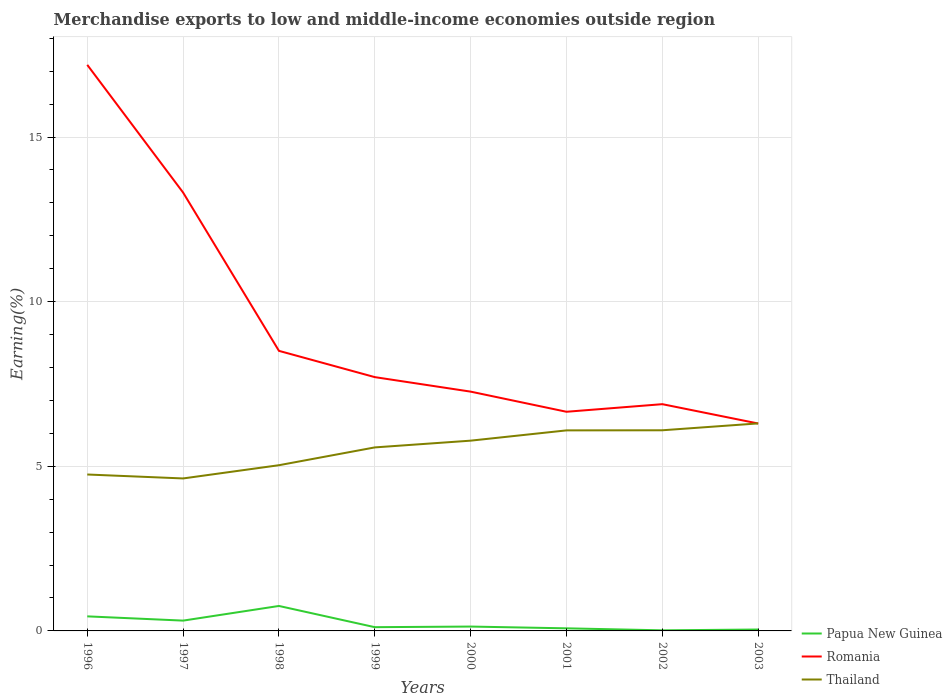How many different coloured lines are there?
Provide a succinct answer. 3. Does the line corresponding to Papua New Guinea intersect with the line corresponding to Thailand?
Your answer should be very brief. No. Is the number of lines equal to the number of legend labels?
Make the answer very short. Yes. Across all years, what is the maximum percentage of amount earned from merchandise exports in Thailand?
Keep it short and to the point. 4.63. In which year was the percentage of amount earned from merchandise exports in Romania maximum?
Give a very brief answer. 2003. What is the total percentage of amount earned from merchandise exports in Papua New Guinea in the graph?
Offer a very short reply. 0.27. What is the difference between the highest and the second highest percentage of amount earned from merchandise exports in Papua New Guinea?
Your response must be concise. 0.74. Is the percentage of amount earned from merchandise exports in Papua New Guinea strictly greater than the percentage of amount earned from merchandise exports in Romania over the years?
Keep it short and to the point. Yes. How many lines are there?
Give a very brief answer. 3. What is the difference between two consecutive major ticks on the Y-axis?
Offer a very short reply. 5. Are the values on the major ticks of Y-axis written in scientific E-notation?
Offer a very short reply. No. Does the graph contain grids?
Your response must be concise. Yes. How many legend labels are there?
Keep it short and to the point. 3. What is the title of the graph?
Ensure brevity in your answer.  Merchandise exports to low and middle-income economies outside region. Does "Azerbaijan" appear as one of the legend labels in the graph?
Your answer should be compact. No. What is the label or title of the X-axis?
Keep it short and to the point. Years. What is the label or title of the Y-axis?
Your answer should be very brief. Earning(%). What is the Earning(%) of Papua New Guinea in 1996?
Ensure brevity in your answer.  0.44. What is the Earning(%) in Romania in 1996?
Offer a terse response. 17.19. What is the Earning(%) in Thailand in 1996?
Provide a succinct answer. 4.75. What is the Earning(%) of Papua New Guinea in 1997?
Your answer should be compact. 0.31. What is the Earning(%) of Romania in 1997?
Your answer should be compact. 13.31. What is the Earning(%) of Thailand in 1997?
Offer a very short reply. 4.63. What is the Earning(%) in Papua New Guinea in 1998?
Ensure brevity in your answer.  0.76. What is the Earning(%) in Romania in 1998?
Make the answer very short. 8.51. What is the Earning(%) in Thailand in 1998?
Make the answer very short. 5.03. What is the Earning(%) in Papua New Guinea in 1999?
Keep it short and to the point. 0.11. What is the Earning(%) in Romania in 1999?
Ensure brevity in your answer.  7.71. What is the Earning(%) in Thailand in 1999?
Ensure brevity in your answer.  5.57. What is the Earning(%) in Papua New Guinea in 2000?
Provide a short and direct response. 0.13. What is the Earning(%) in Romania in 2000?
Your answer should be very brief. 7.27. What is the Earning(%) in Thailand in 2000?
Give a very brief answer. 5.78. What is the Earning(%) of Papua New Guinea in 2001?
Your response must be concise. 0.08. What is the Earning(%) in Romania in 2001?
Provide a succinct answer. 6.66. What is the Earning(%) of Thailand in 2001?
Keep it short and to the point. 6.09. What is the Earning(%) in Papua New Guinea in 2002?
Offer a terse response. 0.02. What is the Earning(%) of Romania in 2002?
Your response must be concise. 6.89. What is the Earning(%) in Thailand in 2002?
Keep it short and to the point. 6.09. What is the Earning(%) in Papua New Guinea in 2003?
Give a very brief answer. 0.04. What is the Earning(%) of Romania in 2003?
Offer a terse response. 6.3. What is the Earning(%) in Thailand in 2003?
Your answer should be very brief. 6.3. Across all years, what is the maximum Earning(%) in Papua New Guinea?
Your answer should be very brief. 0.76. Across all years, what is the maximum Earning(%) in Romania?
Give a very brief answer. 17.19. Across all years, what is the maximum Earning(%) of Thailand?
Provide a short and direct response. 6.3. Across all years, what is the minimum Earning(%) in Papua New Guinea?
Keep it short and to the point. 0.02. Across all years, what is the minimum Earning(%) of Romania?
Ensure brevity in your answer.  6.3. Across all years, what is the minimum Earning(%) in Thailand?
Give a very brief answer. 4.63. What is the total Earning(%) in Papua New Guinea in the graph?
Your response must be concise. 1.9. What is the total Earning(%) in Romania in the graph?
Give a very brief answer. 73.83. What is the total Earning(%) in Thailand in the graph?
Ensure brevity in your answer.  44.26. What is the difference between the Earning(%) of Papua New Guinea in 1996 and that in 1997?
Provide a short and direct response. 0.13. What is the difference between the Earning(%) of Romania in 1996 and that in 1997?
Your answer should be compact. 3.88. What is the difference between the Earning(%) of Thailand in 1996 and that in 1997?
Your answer should be compact. 0.12. What is the difference between the Earning(%) in Papua New Guinea in 1996 and that in 1998?
Give a very brief answer. -0.32. What is the difference between the Earning(%) in Romania in 1996 and that in 1998?
Offer a very short reply. 8.69. What is the difference between the Earning(%) of Thailand in 1996 and that in 1998?
Your answer should be compact. -0.28. What is the difference between the Earning(%) of Papua New Guinea in 1996 and that in 1999?
Your answer should be very brief. 0.33. What is the difference between the Earning(%) of Romania in 1996 and that in 1999?
Your answer should be compact. 9.48. What is the difference between the Earning(%) in Thailand in 1996 and that in 1999?
Provide a short and direct response. -0.82. What is the difference between the Earning(%) in Papua New Guinea in 1996 and that in 2000?
Ensure brevity in your answer.  0.31. What is the difference between the Earning(%) in Romania in 1996 and that in 2000?
Ensure brevity in your answer.  9.93. What is the difference between the Earning(%) in Thailand in 1996 and that in 2000?
Offer a terse response. -1.03. What is the difference between the Earning(%) in Papua New Guinea in 1996 and that in 2001?
Offer a very short reply. 0.36. What is the difference between the Earning(%) of Romania in 1996 and that in 2001?
Your answer should be very brief. 10.54. What is the difference between the Earning(%) in Thailand in 1996 and that in 2001?
Your answer should be compact. -1.34. What is the difference between the Earning(%) in Papua New Guinea in 1996 and that in 2002?
Offer a very short reply. 0.42. What is the difference between the Earning(%) of Romania in 1996 and that in 2002?
Your response must be concise. 10.31. What is the difference between the Earning(%) of Thailand in 1996 and that in 2002?
Your answer should be compact. -1.34. What is the difference between the Earning(%) of Papua New Guinea in 1996 and that in 2003?
Offer a terse response. 0.4. What is the difference between the Earning(%) in Romania in 1996 and that in 2003?
Provide a succinct answer. 10.89. What is the difference between the Earning(%) in Thailand in 1996 and that in 2003?
Your response must be concise. -1.55. What is the difference between the Earning(%) of Papua New Guinea in 1997 and that in 1998?
Make the answer very short. -0.45. What is the difference between the Earning(%) of Romania in 1997 and that in 1998?
Your response must be concise. 4.81. What is the difference between the Earning(%) in Thailand in 1997 and that in 1998?
Provide a succinct answer. -0.4. What is the difference between the Earning(%) in Papua New Guinea in 1997 and that in 1999?
Keep it short and to the point. 0.2. What is the difference between the Earning(%) in Romania in 1997 and that in 1999?
Your answer should be compact. 5.61. What is the difference between the Earning(%) in Thailand in 1997 and that in 1999?
Provide a succinct answer. -0.94. What is the difference between the Earning(%) in Papua New Guinea in 1997 and that in 2000?
Give a very brief answer. 0.18. What is the difference between the Earning(%) of Romania in 1997 and that in 2000?
Your answer should be compact. 6.05. What is the difference between the Earning(%) in Thailand in 1997 and that in 2000?
Ensure brevity in your answer.  -1.15. What is the difference between the Earning(%) of Papua New Guinea in 1997 and that in 2001?
Your response must be concise. 0.23. What is the difference between the Earning(%) in Romania in 1997 and that in 2001?
Offer a very short reply. 6.66. What is the difference between the Earning(%) in Thailand in 1997 and that in 2001?
Offer a terse response. -1.46. What is the difference between the Earning(%) of Papua New Guinea in 1997 and that in 2002?
Keep it short and to the point. 0.29. What is the difference between the Earning(%) in Romania in 1997 and that in 2002?
Offer a terse response. 6.43. What is the difference between the Earning(%) in Thailand in 1997 and that in 2002?
Give a very brief answer. -1.46. What is the difference between the Earning(%) of Papua New Guinea in 1997 and that in 2003?
Your answer should be compact. 0.27. What is the difference between the Earning(%) of Romania in 1997 and that in 2003?
Keep it short and to the point. 7.01. What is the difference between the Earning(%) of Thailand in 1997 and that in 2003?
Make the answer very short. -1.67. What is the difference between the Earning(%) in Papua New Guinea in 1998 and that in 1999?
Provide a succinct answer. 0.64. What is the difference between the Earning(%) of Romania in 1998 and that in 1999?
Make the answer very short. 0.8. What is the difference between the Earning(%) of Thailand in 1998 and that in 1999?
Your answer should be compact. -0.54. What is the difference between the Earning(%) of Papua New Guinea in 1998 and that in 2000?
Keep it short and to the point. 0.63. What is the difference between the Earning(%) of Romania in 1998 and that in 2000?
Your answer should be very brief. 1.24. What is the difference between the Earning(%) of Thailand in 1998 and that in 2000?
Your answer should be compact. -0.75. What is the difference between the Earning(%) of Papua New Guinea in 1998 and that in 2001?
Give a very brief answer. 0.68. What is the difference between the Earning(%) of Romania in 1998 and that in 2001?
Make the answer very short. 1.85. What is the difference between the Earning(%) in Thailand in 1998 and that in 2001?
Offer a very short reply. -1.06. What is the difference between the Earning(%) in Papua New Guinea in 1998 and that in 2002?
Make the answer very short. 0.74. What is the difference between the Earning(%) in Romania in 1998 and that in 2002?
Your answer should be very brief. 1.62. What is the difference between the Earning(%) of Thailand in 1998 and that in 2002?
Your answer should be compact. -1.06. What is the difference between the Earning(%) in Papua New Guinea in 1998 and that in 2003?
Give a very brief answer. 0.72. What is the difference between the Earning(%) in Romania in 1998 and that in 2003?
Your answer should be very brief. 2.21. What is the difference between the Earning(%) in Thailand in 1998 and that in 2003?
Your response must be concise. -1.27. What is the difference between the Earning(%) of Papua New Guinea in 1999 and that in 2000?
Provide a succinct answer. -0.02. What is the difference between the Earning(%) in Romania in 1999 and that in 2000?
Make the answer very short. 0.44. What is the difference between the Earning(%) of Thailand in 1999 and that in 2000?
Give a very brief answer. -0.21. What is the difference between the Earning(%) in Papua New Guinea in 1999 and that in 2001?
Provide a succinct answer. 0.03. What is the difference between the Earning(%) of Romania in 1999 and that in 2001?
Provide a short and direct response. 1.05. What is the difference between the Earning(%) of Thailand in 1999 and that in 2001?
Provide a succinct answer. -0.52. What is the difference between the Earning(%) in Papua New Guinea in 1999 and that in 2002?
Give a very brief answer. 0.1. What is the difference between the Earning(%) in Romania in 1999 and that in 2002?
Your response must be concise. 0.82. What is the difference between the Earning(%) of Thailand in 1999 and that in 2002?
Your response must be concise. -0.52. What is the difference between the Earning(%) in Papua New Guinea in 1999 and that in 2003?
Offer a terse response. 0.07. What is the difference between the Earning(%) in Romania in 1999 and that in 2003?
Ensure brevity in your answer.  1.41. What is the difference between the Earning(%) in Thailand in 1999 and that in 2003?
Offer a terse response. -0.73. What is the difference between the Earning(%) in Papua New Guinea in 2000 and that in 2001?
Ensure brevity in your answer.  0.05. What is the difference between the Earning(%) in Romania in 2000 and that in 2001?
Provide a short and direct response. 0.61. What is the difference between the Earning(%) in Thailand in 2000 and that in 2001?
Ensure brevity in your answer.  -0.31. What is the difference between the Earning(%) in Papua New Guinea in 2000 and that in 2002?
Make the answer very short. 0.11. What is the difference between the Earning(%) in Romania in 2000 and that in 2002?
Your answer should be very brief. 0.38. What is the difference between the Earning(%) of Thailand in 2000 and that in 2002?
Offer a terse response. -0.32. What is the difference between the Earning(%) in Papua New Guinea in 2000 and that in 2003?
Your answer should be compact. 0.09. What is the difference between the Earning(%) of Romania in 2000 and that in 2003?
Make the answer very short. 0.97. What is the difference between the Earning(%) of Thailand in 2000 and that in 2003?
Your answer should be compact. -0.52. What is the difference between the Earning(%) in Papua New Guinea in 2001 and that in 2002?
Your answer should be compact. 0.06. What is the difference between the Earning(%) in Romania in 2001 and that in 2002?
Provide a short and direct response. -0.23. What is the difference between the Earning(%) in Thailand in 2001 and that in 2002?
Offer a very short reply. -0. What is the difference between the Earning(%) of Papua New Guinea in 2001 and that in 2003?
Provide a short and direct response. 0.04. What is the difference between the Earning(%) in Romania in 2001 and that in 2003?
Provide a short and direct response. 0.36. What is the difference between the Earning(%) in Thailand in 2001 and that in 2003?
Offer a terse response. -0.21. What is the difference between the Earning(%) in Papua New Guinea in 2002 and that in 2003?
Provide a succinct answer. -0.02. What is the difference between the Earning(%) of Romania in 2002 and that in 2003?
Your response must be concise. 0.59. What is the difference between the Earning(%) of Thailand in 2002 and that in 2003?
Keep it short and to the point. -0.21. What is the difference between the Earning(%) in Papua New Guinea in 1996 and the Earning(%) in Romania in 1997?
Provide a short and direct response. -12.87. What is the difference between the Earning(%) in Papua New Guinea in 1996 and the Earning(%) in Thailand in 1997?
Make the answer very short. -4.19. What is the difference between the Earning(%) of Romania in 1996 and the Earning(%) of Thailand in 1997?
Provide a short and direct response. 12.56. What is the difference between the Earning(%) of Papua New Guinea in 1996 and the Earning(%) of Romania in 1998?
Your answer should be compact. -8.06. What is the difference between the Earning(%) of Papua New Guinea in 1996 and the Earning(%) of Thailand in 1998?
Provide a succinct answer. -4.59. What is the difference between the Earning(%) in Romania in 1996 and the Earning(%) in Thailand in 1998?
Offer a terse response. 12.16. What is the difference between the Earning(%) of Papua New Guinea in 1996 and the Earning(%) of Romania in 1999?
Your response must be concise. -7.27. What is the difference between the Earning(%) of Papua New Guinea in 1996 and the Earning(%) of Thailand in 1999?
Ensure brevity in your answer.  -5.13. What is the difference between the Earning(%) of Romania in 1996 and the Earning(%) of Thailand in 1999?
Offer a terse response. 11.62. What is the difference between the Earning(%) of Papua New Guinea in 1996 and the Earning(%) of Romania in 2000?
Ensure brevity in your answer.  -6.83. What is the difference between the Earning(%) of Papua New Guinea in 1996 and the Earning(%) of Thailand in 2000?
Provide a succinct answer. -5.34. What is the difference between the Earning(%) of Romania in 1996 and the Earning(%) of Thailand in 2000?
Offer a terse response. 11.41. What is the difference between the Earning(%) of Papua New Guinea in 1996 and the Earning(%) of Romania in 2001?
Offer a terse response. -6.21. What is the difference between the Earning(%) in Papua New Guinea in 1996 and the Earning(%) in Thailand in 2001?
Keep it short and to the point. -5.65. What is the difference between the Earning(%) of Romania in 1996 and the Earning(%) of Thailand in 2001?
Your response must be concise. 11.1. What is the difference between the Earning(%) in Papua New Guinea in 1996 and the Earning(%) in Romania in 2002?
Provide a short and direct response. -6.44. What is the difference between the Earning(%) in Papua New Guinea in 1996 and the Earning(%) in Thailand in 2002?
Offer a terse response. -5.65. What is the difference between the Earning(%) of Romania in 1996 and the Earning(%) of Thailand in 2002?
Your answer should be compact. 11.1. What is the difference between the Earning(%) in Papua New Guinea in 1996 and the Earning(%) in Romania in 2003?
Keep it short and to the point. -5.86. What is the difference between the Earning(%) in Papua New Guinea in 1996 and the Earning(%) in Thailand in 2003?
Your response must be concise. -5.86. What is the difference between the Earning(%) in Romania in 1996 and the Earning(%) in Thailand in 2003?
Your answer should be compact. 10.89. What is the difference between the Earning(%) of Papua New Guinea in 1997 and the Earning(%) of Romania in 1998?
Provide a succinct answer. -8.19. What is the difference between the Earning(%) of Papua New Guinea in 1997 and the Earning(%) of Thailand in 1998?
Offer a very short reply. -4.72. What is the difference between the Earning(%) in Romania in 1997 and the Earning(%) in Thailand in 1998?
Provide a short and direct response. 8.28. What is the difference between the Earning(%) of Papua New Guinea in 1997 and the Earning(%) of Romania in 1999?
Give a very brief answer. -7.4. What is the difference between the Earning(%) in Papua New Guinea in 1997 and the Earning(%) in Thailand in 1999?
Your answer should be very brief. -5.26. What is the difference between the Earning(%) of Romania in 1997 and the Earning(%) of Thailand in 1999?
Keep it short and to the point. 7.74. What is the difference between the Earning(%) in Papua New Guinea in 1997 and the Earning(%) in Romania in 2000?
Your answer should be very brief. -6.95. What is the difference between the Earning(%) in Papua New Guinea in 1997 and the Earning(%) in Thailand in 2000?
Keep it short and to the point. -5.47. What is the difference between the Earning(%) of Romania in 1997 and the Earning(%) of Thailand in 2000?
Keep it short and to the point. 7.54. What is the difference between the Earning(%) in Papua New Guinea in 1997 and the Earning(%) in Romania in 2001?
Your answer should be compact. -6.34. What is the difference between the Earning(%) of Papua New Guinea in 1997 and the Earning(%) of Thailand in 2001?
Ensure brevity in your answer.  -5.78. What is the difference between the Earning(%) in Romania in 1997 and the Earning(%) in Thailand in 2001?
Offer a terse response. 7.22. What is the difference between the Earning(%) of Papua New Guinea in 1997 and the Earning(%) of Romania in 2002?
Your answer should be compact. -6.57. What is the difference between the Earning(%) in Papua New Guinea in 1997 and the Earning(%) in Thailand in 2002?
Provide a succinct answer. -5.78. What is the difference between the Earning(%) in Romania in 1997 and the Earning(%) in Thailand in 2002?
Provide a succinct answer. 7.22. What is the difference between the Earning(%) in Papua New Guinea in 1997 and the Earning(%) in Romania in 2003?
Provide a short and direct response. -5.99. What is the difference between the Earning(%) of Papua New Guinea in 1997 and the Earning(%) of Thailand in 2003?
Provide a succinct answer. -5.99. What is the difference between the Earning(%) in Romania in 1997 and the Earning(%) in Thailand in 2003?
Your answer should be very brief. 7.01. What is the difference between the Earning(%) in Papua New Guinea in 1998 and the Earning(%) in Romania in 1999?
Offer a terse response. -6.95. What is the difference between the Earning(%) in Papua New Guinea in 1998 and the Earning(%) in Thailand in 1999?
Your response must be concise. -4.82. What is the difference between the Earning(%) in Romania in 1998 and the Earning(%) in Thailand in 1999?
Provide a succinct answer. 2.93. What is the difference between the Earning(%) of Papua New Guinea in 1998 and the Earning(%) of Romania in 2000?
Your response must be concise. -6.51. What is the difference between the Earning(%) of Papua New Guinea in 1998 and the Earning(%) of Thailand in 2000?
Keep it short and to the point. -5.02. What is the difference between the Earning(%) in Romania in 1998 and the Earning(%) in Thailand in 2000?
Keep it short and to the point. 2.73. What is the difference between the Earning(%) in Papua New Guinea in 1998 and the Earning(%) in Romania in 2001?
Keep it short and to the point. -5.9. What is the difference between the Earning(%) of Papua New Guinea in 1998 and the Earning(%) of Thailand in 2001?
Your answer should be compact. -5.33. What is the difference between the Earning(%) in Romania in 1998 and the Earning(%) in Thailand in 2001?
Provide a succinct answer. 2.42. What is the difference between the Earning(%) of Papua New Guinea in 1998 and the Earning(%) of Romania in 2002?
Provide a succinct answer. -6.13. What is the difference between the Earning(%) of Papua New Guinea in 1998 and the Earning(%) of Thailand in 2002?
Provide a succinct answer. -5.34. What is the difference between the Earning(%) in Romania in 1998 and the Earning(%) in Thailand in 2002?
Your answer should be compact. 2.41. What is the difference between the Earning(%) of Papua New Guinea in 1998 and the Earning(%) of Romania in 2003?
Your answer should be very brief. -5.54. What is the difference between the Earning(%) in Papua New Guinea in 1998 and the Earning(%) in Thailand in 2003?
Keep it short and to the point. -5.54. What is the difference between the Earning(%) of Romania in 1998 and the Earning(%) of Thailand in 2003?
Make the answer very short. 2.2. What is the difference between the Earning(%) of Papua New Guinea in 1999 and the Earning(%) of Romania in 2000?
Offer a terse response. -7.15. What is the difference between the Earning(%) of Papua New Guinea in 1999 and the Earning(%) of Thailand in 2000?
Your answer should be compact. -5.67. What is the difference between the Earning(%) in Romania in 1999 and the Earning(%) in Thailand in 2000?
Your answer should be very brief. 1.93. What is the difference between the Earning(%) of Papua New Guinea in 1999 and the Earning(%) of Romania in 2001?
Provide a succinct answer. -6.54. What is the difference between the Earning(%) of Papua New Guinea in 1999 and the Earning(%) of Thailand in 2001?
Your answer should be compact. -5.98. What is the difference between the Earning(%) of Romania in 1999 and the Earning(%) of Thailand in 2001?
Ensure brevity in your answer.  1.62. What is the difference between the Earning(%) in Papua New Guinea in 1999 and the Earning(%) in Romania in 2002?
Make the answer very short. -6.77. What is the difference between the Earning(%) in Papua New Guinea in 1999 and the Earning(%) in Thailand in 2002?
Ensure brevity in your answer.  -5.98. What is the difference between the Earning(%) in Romania in 1999 and the Earning(%) in Thailand in 2002?
Provide a succinct answer. 1.61. What is the difference between the Earning(%) in Papua New Guinea in 1999 and the Earning(%) in Romania in 2003?
Provide a succinct answer. -6.19. What is the difference between the Earning(%) of Papua New Guinea in 1999 and the Earning(%) of Thailand in 2003?
Make the answer very short. -6.19. What is the difference between the Earning(%) in Romania in 1999 and the Earning(%) in Thailand in 2003?
Make the answer very short. 1.41. What is the difference between the Earning(%) in Papua New Guinea in 2000 and the Earning(%) in Romania in 2001?
Provide a short and direct response. -6.52. What is the difference between the Earning(%) in Papua New Guinea in 2000 and the Earning(%) in Thailand in 2001?
Your response must be concise. -5.96. What is the difference between the Earning(%) of Romania in 2000 and the Earning(%) of Thailand in 2001?
Your answer should be compact. 1.18. What is the difference between the Earning(%) in Papua New Guinea in 2000 and the Earning(%) in Romania in 2002?
Give a very brief answer. -6.75. What is the difference between the Earning(%) in Papua New Guinea in 2000 and the Earning(%) in Thailand in 2002?
Provide a short and direct response. -5.96. What is the difference between the Earning(%) of Romania in 2000 and the Earning(%) of Thailand in 2002?
Your answer should be compact. 1.17. What is the difference between the Earning(%) in Papua New Guinea in 2000 and the Earning(%) in Romania in 2003?
Give a very brief answer. -6.17. What is the difference between the Earning(%) of Papua New Guinea in 2000 and the Earning(%) of Thailand in 2003?
Provide a succinct answer. -6.17. What is the difference between the Earning(%) of Romania in 2000 and the Earning(%) of Thailand in 2003?
Your response must be concise. 0.96. What is the difference between the Earning(%) of Papua New Guinea in 2001 and the Earning(%) of Romania in 2002?
Ensure brevity in your answer.  -6.81. What is the difference between the Earning(%) in Papua New Guinea in 2001 and the Earning(%) in Thailand in 2002?
Keep it short and to the point. -6.02. What is the difference between the Earning(%) of Romania in 2001 and the Earning(%) of Thailand in 2002?
Your response must be concise. 0.56. What is the difference between the Earning(%) of Papua New Guinea in 2001 and the Earning(%) of Romania in 2003?
Your answer should be compact. -6.22. What is the difference between the Earning(%) of Papua New Guinea in 2001 and the Earning(%) of Thailand in 2003?
Provide a succinct answer. -6.22. What is the difference between the Earning(%) in Romania in 2001 and the Earning(%) in Thailand in 2003?
Give a very brief answer. 0.35. What is the difference between the Earning(%) of Papua New Guinea in 2002 and the Earning(%) of Romania in 2003?
Offer a very short reply. -6.28. What is the difference between the Earning(%) in Papua New Guinea in 2002 and the Earning(%) in Thailand in 2003?
Offer a terse response. -6.28. What is the difference between the Earning(%) of Romania in 2002 and the Earning(%) of Thailand in 2003?
Make the answer very short. 0.58. What is the average Earning(%) in Papua New Guinea per year?
Make the answer very short. 0.24. What is the average Earning(%) of Romania per year?
Give a very brief answer. 9.23. What is the average Earning(%) of Thailand per year?
Your answer should be very brief. 5.53. In the year 1996, what is the difference between the Earning(%) in Papua New Guinea and Earning(%) in Romania?
Provide a succinct answer. -16.75. In the year 1996, what is the difference between the Earning(%) of Papua New Guinea and Earning(%) of Thailand?
Offer a very short reply. -4.31. In the year 1996, what is the difference between the Earning(%) in Romania and Earning(%) in Thailand?
Provide a succinct answer. 12.44. In the year 1997, what is the difference between the Earning(%) of Papua New Guinea and Earning(%) of Romania?
Offer a terse response. -13. In the year 1997, what is the difference between the Earning(%) in Papua New Guinea and Earning(%) in Thailand?
Make the answer very short. -4.32. In the year 1997, what is the difference between the Earning(%) of Romania and Earning(%) of Thailand?
Offer a terse response. 8.68. In the year 1998, what is the difference between the Earning(%) in Papua New Guinea and Earning(%) in Romania?
Give a very brief answer. -7.75. In the year 1998, what is the difference between the Earning(%) in Papua New Guinea and Earning(%) in Thailand?
Your response must be concise. -4.27. In the year 1998, what is the difference between the Earning(%) in Romania and Earning(%) in Thailand?
Ensure brevity in your answer.  3.47. In the year 1999, what is the difference between the Earning(%) of Papua New Guinea and Earning(%) of Romania?
Your answer should be very brief. -7.59. In the year 1999, what is the difference between the Earning(%) in Papua New Guinea and Earning(%) in Thailand?
Your answer should be compact. -5.46. In the year 1999, what is the difference between the Earning(%) of Romania and Earning(%) of Thailand?
Your answer should be compact. 2.13. In the year 2000, what is the difference between the Earning(%) in Papua New Guinea and Earning(%) in Romania?
Provide a succinct answer. -7.14. In the year 2000, what is the difference between the Earning(%) of Papua New Guinea and Earning(%) of Thailand?
Ensure brevity in your answer.  -5.65. In the year 2000, what is the difference between the Earning(%) of Romania and Earning(%) of Thailand?
Offer a very short reply. 1.49. In the year 2001, what is the difference between the Earning(%) of Papua New Guinea and Earning(%) of Romania?
Ensure brevity in your answer.  -6.58. In the year 2001, what is the difference between the Earning(%) in Papua New Guinea and Earning(%) in Thailand?
Provide a short and direct response. -6.01. In the year 2001, what is the difference between the Earning(%) in Romania and Earning(%) in Thailand?
Provide a succinct answer. 0.57. In the year 2002, what is the difference between the Earning(%) of Papua New Guinea and Earning(%) of Romania?
Provide a short and direct response. -6.87. In the year 2002, what is the difference between the Earning(%) in Papua New Guinea and Earning(%) in Thailand?
Make the answer very short. -6.08. In the year 2002, what is the difference between the Earning(%) in Romania and Earning(%) in Thailand?
Make the answer very short. 0.79. In the year 2003, what is the difference between the Earning(%) of Papua New Guinea and Earning(%) of Romania?
Give a very brief answer. -6.26. In the year 2003, what is the difference between the Earning(%) of Papua New Guinea and Earning(%) of Thailand?
Offer a very short reply. -6.26. In the year 2003, what is the difference between the Earning(%) of Romania and Earning(%) of Thailand?
Offer a very short reply. -0. What is the ratio of the Earning(%) of Papua New Guinea in 1996 to that in 1997?
Keep it short and to the point. 1.41. What is the ratio of the Earning(%) of Romania in 1996 to that in 1997?
Your response must be concise. 1.29. What is the ratio of the Earning(%) in Thailand in 1996 to that in 1997?
Provide a succinct answer. 1.03. What is the ratio of the Earning(%) of Papua New Guinea in 1996 to that in 1998?
Offer a terse response. 0.58. What is the ratio of the Earning(%) in Romania in 1996 to that in 1998?
Your answer should be very brief. 2.02. What is the ratio of the Earning(%) of Thailand in 1996 to that in 1998?
Ensure brevity in your answer.  0.94. What is the ratio of the Earning(%) in Papua New Guinea in 1996 to that in 1999?
Give a very brief answer. 3.89. What is the ratio of the Earning(%) in Romania in 1996 to that in 1999?
Provide a short and direct response. 2.23. What is the ratio of the Earning(%) in Thailand in 1996 to that in 1999?
Give a very brief answer. 0.85. What is the ratio of the Earning(%) in Papua New Guinea in 1996 to that in 2000?
Your answer should be compact. 3.34. What is the ratio of the Earning(%) in Romania in 1996 to that in 2000?
Ensure brevity in your answer.  2.37. What is the ratio of the Earning(%) of Thailand in 1996 to that in 2000?
Provide a succinct answer. 0.82. What is the ratio of the Earning(%) of Papua New Guinea in 1996 to that in 2001?
Give a very brief answer. 5.61. What is the ratio of the Earning(%) in Romania in 1996 to that in 2001?
Provide a succinct answer. 2.58. What is the ratio of the Earning(%) of Thailand in 1996 to that in 2001?
Ensure brevity in your answer.  0.78. What is the ratio of the Earning(%) in Papua New Guinea in 1996 to that in 2002?
Keep it short and to the point. 24.5. What is the ratio of the Earning(%) in Romania in 1996 to that in 2002?
Offer a terse response. 2.5. What is the ratio of the Earning(%) of Thailand in 1996 to that in 2002?
Offer a very short reply. 0.78. What is the ratio of the Earning(%) of Papua New Guinea in 1996 to that in 2003?
Give a very brief answer. 10.35. What is the ratio of the Earning(%) of Romania in 1996 to that in 2003?
Make the answer very short. 2.73. What is the ratio of the Earning(%) of Thailand in 1996 to that in 2003?
Your response must be concise. 0.75. What is the ratio of the Earning(%) in Papua New Guinea in 1997 to that in 1998?
Provide a short and direct response. 0.41. What is the ratio of the Earning(%) in Romania in 1997 to that in 1998?
Offer a terse response. 1.57. What is the ratio of the Earning(%) of Thailand in 1997 to that in 1998?
Your answer should be compact. 0.92. What is the ratio of the Earning(%) of Papua New Guinea in 1997 to that in 1999?
Your answer should be very brief. 2.75. What is the ratio of the Earning(%) in Romania in 1997 to that in 1999?
Offer a very short reply. 1.73. What is the ratio of the Earning(%) of Thailand in 1997 to that in 1999?
Give a very brief answer. 0.83. What is the ratio of the Earning(%) of Papua New Guinea in 1997 to that in 2000?
Make the answer very short. 2.36. What is the ratio of the Earning(%) in Romania in 1997 to that in 2000?
Ensure brevity in your answer.  1.83. What is the ratio of the Earning(%) in Thailand in 1997 to that in 2000?
Offer a terse response. 0.8. What is the ratio of the Earning(%) in Papua New Guinea in 1997 to that in 2001?
Keep it short and to the point. 3.97. What is the ratio of the Earning(%) in Romania in 1997 to that in 2001?
Ensure brevity in your answer.  2. What is the ratio of the Earning(%) in Thailand in 1997 to that in 2001?
Make the answer very short. 0.76. What is the ratio of the Earning(%) of Papua New Guinea in 1997 to that in 2002?
Provide a succinct answer. 17.34. What is the ratio of the Earning(%) of Romania in 1997 to that in 2002?
Keep it short and to the point. 1.93. What is the ratio of the Earning(%) in Thailand in 1997 to that in 2002?
Your answer should be compact. 0.76. What is the ratio of the Earning(%) of Papua New Guinea in 1997 to that in 2003?
Your response must be concise. 7.33. What is the ratio of the Earning(%) of Romania in 1997 to that in 2003?
Your answer should be very brief. 2.11. What is the ratio of the Earning(%) of Thailand in 1997 to that in 2003?
Your answer should be compact. 0.73. What is the ratio of the Earning(%) in Papua New Guinea in 1998 to that in 1999?
Provide a succinct answer. 6.66. What is the ratio of the Earning(%) in Romania in 1998 to that in 1999?
Offer a terse response. 1.1. What is the ratio of the Earning(%) of Thailand in 1998 to that in 1999?
Make the answer very short. 0.9. What is the ratio of the Earning(%) of Papua New Guinea in 1998 to that in 2000?
Ensure brevity in your answer.  5.72. What is the ratio of the Earning(%) in Romania in 1998 to that in 2000?
Ensure brevity in your answer.  1.17. What is the ratio of the Earning(%) in Thailand in 1998 to that in 2000?
Keep it short and to the point. 0.87. What is the ratio of the Earning(%) of Papua New Guinea in 1998 to that in 2001?
Keep it short and to the point. 9.61. What is the ratio of the Earning(%) of Romania in 1998 to that in 2001?
Ensure brevity in your answer.  1.28. What is the ratio of the Earning(%) of Thailand in 1998 to that in 2001?
Ensure brevity in your answer.  0.83. What is the ratio of the Earning(%) of Papua New Guinea in 1998 to that in 2002?
Your answer should be very brief. 42.01. What is the ratio of the Earning(%) in Romania in 1998 to that in 2002?
Your answer should be compact. 1.24. What is the ratio of the Earning(%) of Thailand in 1998 to that in 2002?
Your answer should be compact. 0.83. What is the ratio of the Earning(%) in Papua New Guinea in 1998 to that in 2003?
Provide a short and direct response. 17.75. What is the ratio of the Earning(%) of Romania in 1998 to that in 2003?
Provide a succinct answer. 1.35. What is the ratio of the Earning(%) of Thailand in 1998 to that in 2003?
Provide a succinct answer. 0.8. What is the ratio of the Earning(%) in Papua New Guinea in 1999 to that in 2000?
Offer a terse response. 0.86. What is the ratio of the Earning(%) in Romania in 1999 to that in 2000?
Your answer should be very brief. 1.06. What is the ratio of the Earning(%) of Thailand in 1999 to that in 2000?
Keep it short and to the point. 0.96. What is the ratio of the Earning(%) of Papua New Guinea in 1999 to that in 2001?
Provide a short and direct response. 1.44. What is the ratio of the Earning(%) in Romania in 1999 to that in 2001?
Your answer should be compact. 1.16. What is the ratio of the Earning(%) of Thailand in 1999 to that in 2001?
Ensure brevity in your answer.  0.92. What is the ratio of the Earning(%) of Papua New Guinea in 1999 to that in 2002?
Give a very brief answer. 6.3. What is the ratio of the Earning(%) in Romania in 1999 to that in 2002?
Offer a terse response. 1.12. What is the ratio of the Earning(%) in Thailand in 1999 to that in 2002?
Give a very brief answer. 0.91. What is the ratio of the Earning(%) of Papua New Guinea in 1999 to that in 2003?
Your answer should be very brief. 2.66. What is the ratio of the Earning(%) of Romania in 1999 to that in 2003?
Offer a terse response. 1.22. What is the ratio of the Earning(%) of Thailand in 1999 to that in 2003?
Your answer should be very brief. 0.88. What is the ratio of the Earning(%) of Papua New Guinea in 2000 to that in 2001?
Keep it short and to the point. 1.68. What is the ratio of the Earning(%) of Romania in 2000 to that in 2001?
Your response must be concise. 1.09. What is the ratio of the Earning(%) of Thailand in 2000 to that in 2001?
Give a very brief answer. 0.95. What is the ratio of the Earning(%) in Papua New Guinea in 2000 to that in 2002?
Ensure brevity in your answer.  7.34. What is the ratio of the Earning(%) in Romania in 2000 to that in 2002?
Provide a short and direct response. 1.06. What is the ratio of the Earning(%) of Thailand in 2000 to that in 2002?
Your response must be concise. 0.95. What is the ratio of the Earning(%) of Papua New Guinea in 2000 to that in 2003?
Keep it short and to the point. 3.1. What is the ratio of the Earning(%) in Romania in 2000 to that in 2003?
Make the answer very short. 1.15. What is the ratio of the Earning(%) of Thailand in 2000 to that in 2003?
Offer a terse response. 0.92. What is the ratio of the Earning(%) in Papua New Guinea in 2001 to that in 2002?
Your answer should be very brief. 4.37. What is the ratio of the Earning(%) in Romania in 2001 to that in 2002?
Your response must be concise. 0.97. What is the ratio of the Earning(%) in Thailand in 2001 to that in 2002?
Your answer should be compact. 1. What is the ratio of the Earning(%) of Papua New Guinea in 2001 to that in 2003?
Keep it short and to the point. 1.85. What is the ratio of the Earning(%) in Romania in 2001 to that in 2003?
Keep it short and to the point. 1.06. What is the ratio of the Earning(%) of Thailand in 2001 to that in 2003?
Your answer should be compact. 0.97. What is the ratio of the Earning(%) in Papua New Guinea in 2002 to that in 2003?
Ensure brevity in your answer.  0.42. What is the ratio of the Earning(%) in Romania in 2002 to that in 2003?
Keep it short and to the point. 1.09. What is the ratio of the Earning(%) of Thailand in 2002 to that in 2003?
Offer a very short reply. 0.97. What is the difference between the highest and the second highest Earning(%) in Papua New Guinea?
Offer a terse response. 0.32. What is the difference between the highest and the second highest Earning(%) of Romania?
Keep it short and to the point. 3.88. What is the difference between the highest and the second highest Earning(%) of Thailand?
Your response must be concise. 0.21. What is the difference between the highest and the lowest Earning(%) of Papua New Guinea?
Your answer should be very brief. 0.74. What is the difference between the highest and the lowest Earning(%) of Romania?
Provide a succinct answer. 10.89. What is the difference between the highest and the lowest Earning(%) of Thailand?
Offer a terse response. 1.67. 